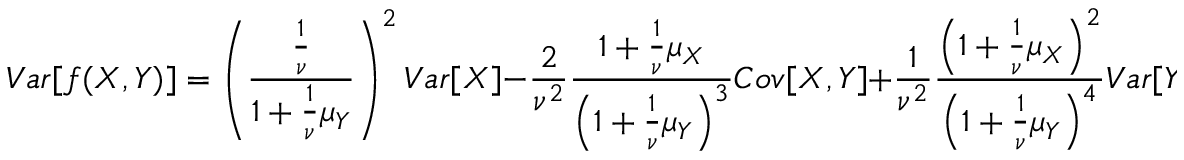<formula> <loc_0><loc_0><loc_500><loc_500>V a r [ f ( X , Y ) ] = \left ( \frac { \frac { 1 } { \nu } } { 1 + \frac { 1 } { \nu } \mu _ { Y } } \right ) ^ { 2 } V a r [ X ] - \frac { 2 } { \nu ^ { 2 } } \frac { 1 + \frac { 1 } { \nu } \mu _ { X } } { \left ( 1 + \frac { 1 } { \nu } \mu _ { Y } \right ) ^ { 3 } } C o v [ X , Y ] + \frac { 1 } { \nu ^ { 2 } } \frac { \left ( 1 + \frac { 1 } { \nu } \mu _ { X } \right ) ^ { 2 } } { \left ( 1 + \frac { 1 } { \nu } \mu _ { Y } \right ) ^ { 4 } } V a r [ Y ]</formula> 